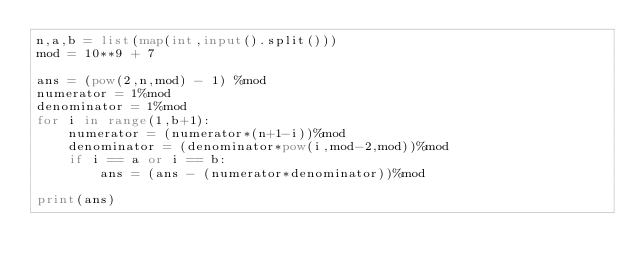Convert code to text. <code><loc_0><loc_0><loc_500><loc_500><_Python_>n,a,b = list(map(int,input().split()))
mod = 10**9 + 7

ans = (pow(2,n,mod) - 1) %mod
numerator = 1%mod
denominator = 1%mod
for i in range(1,b+1):
    numerator = (numerator*(n+1-i))%mod
    denominator = (denominator*pow(i,mod-2,mod))%mod
    if i == a or i == b:
        ans = (ans - (numerator*denominator))%mod

print(ans)</code> 